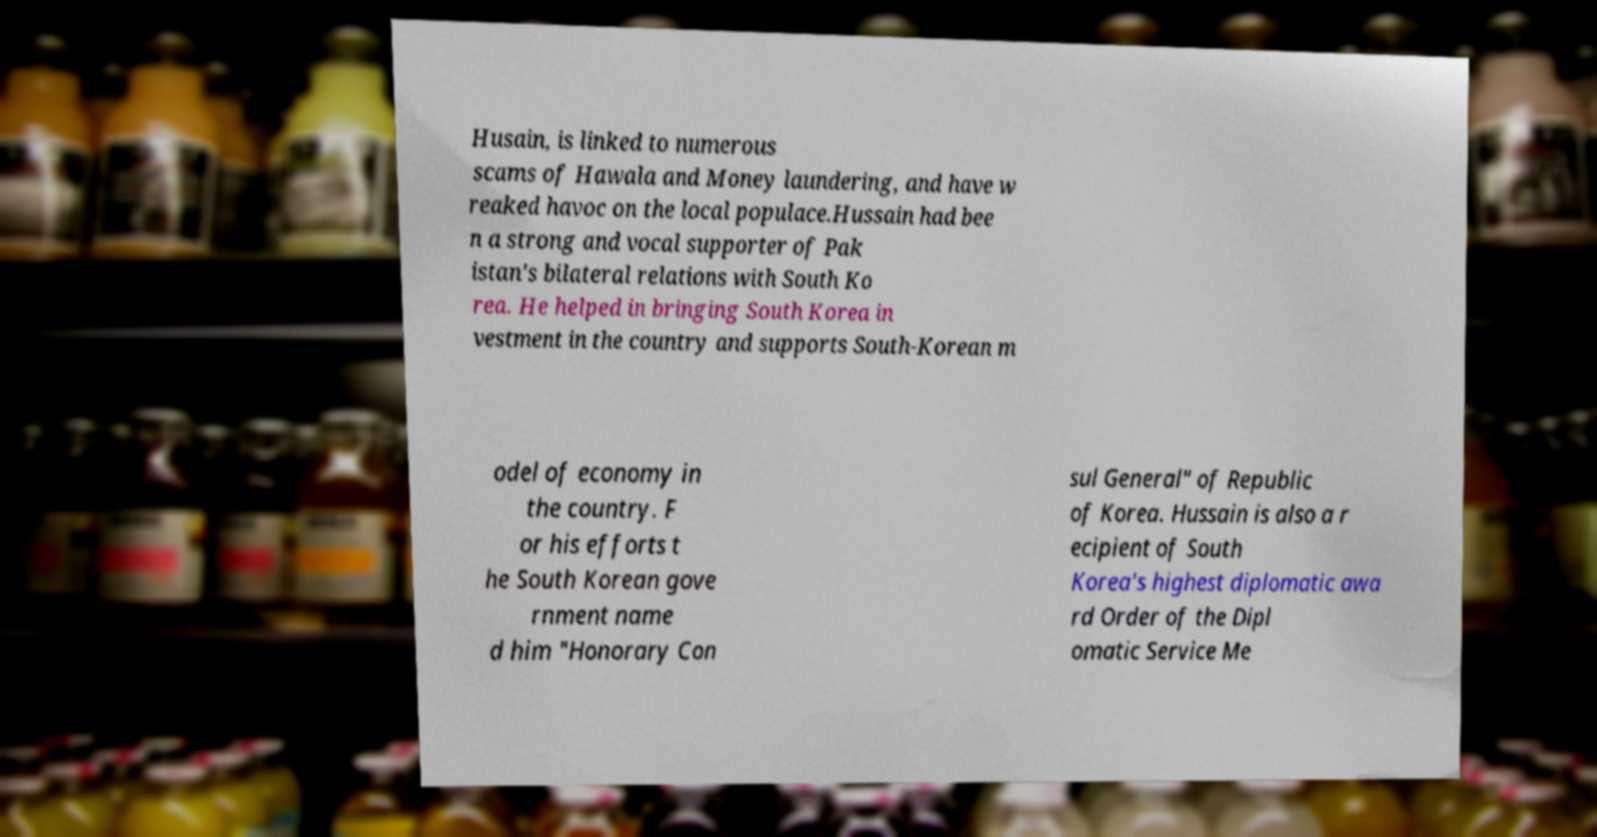I need the written content from this picture converted into text. Can you do that? Husain, is linked to numerous scams of Hawala and Money laundering, and have w reaked havoc on the local populace.Hussain had bee n a strong and vocal supporter of Pak istan's bilateral relations with South Ko rea. He helped in bringing South Korea in vestment in the country and supports South-Korean m odel of economy in the country. F or his efforts t he South Korean gove rnment name d him "Honorary Con sul General" of Republic of Korea. Hussain is also a r ecipient of South Korea's highest diplomatic awa rd Order of the Dipl omatic Service Me 